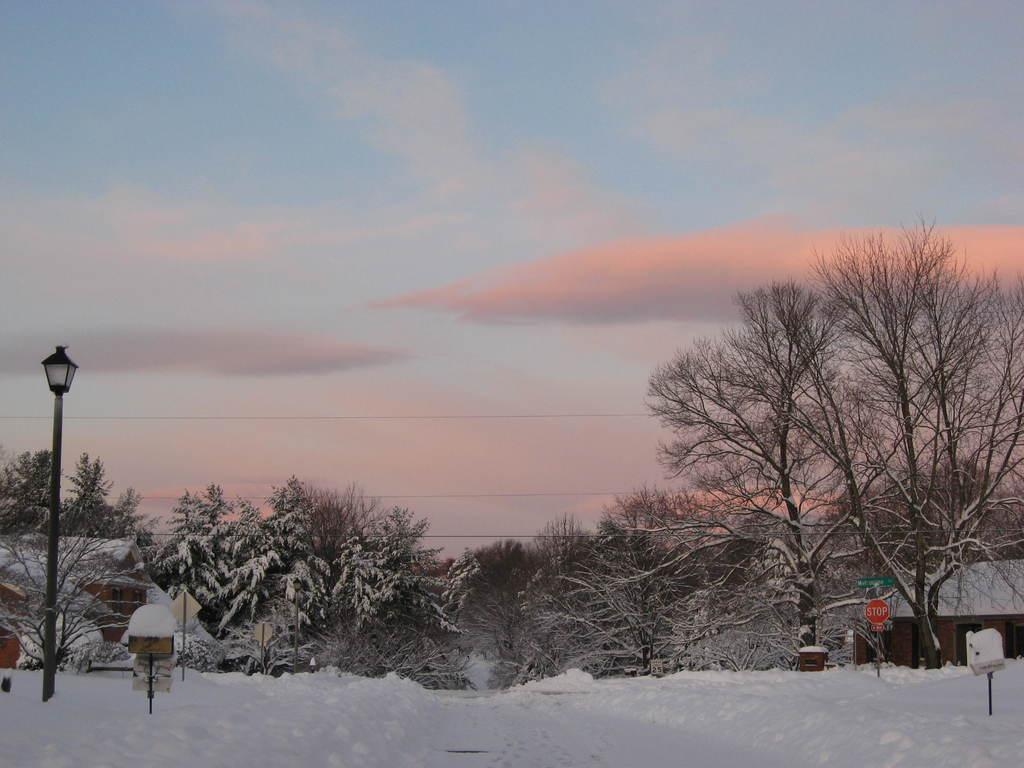What is the condition of the land in the image? There is snow on the land in the image. What can be seen in the middle of the image? There are trees, poles, a sign board, and a house in the middle of the image. What is the color of the sky in the image? The sky is blue with clouds in the image. What is the income of the uncle in the image? There is no information about income or an uncle in the image. How many legs does the tree have in the image? Trees do not have legs; they have trunks and branches. 